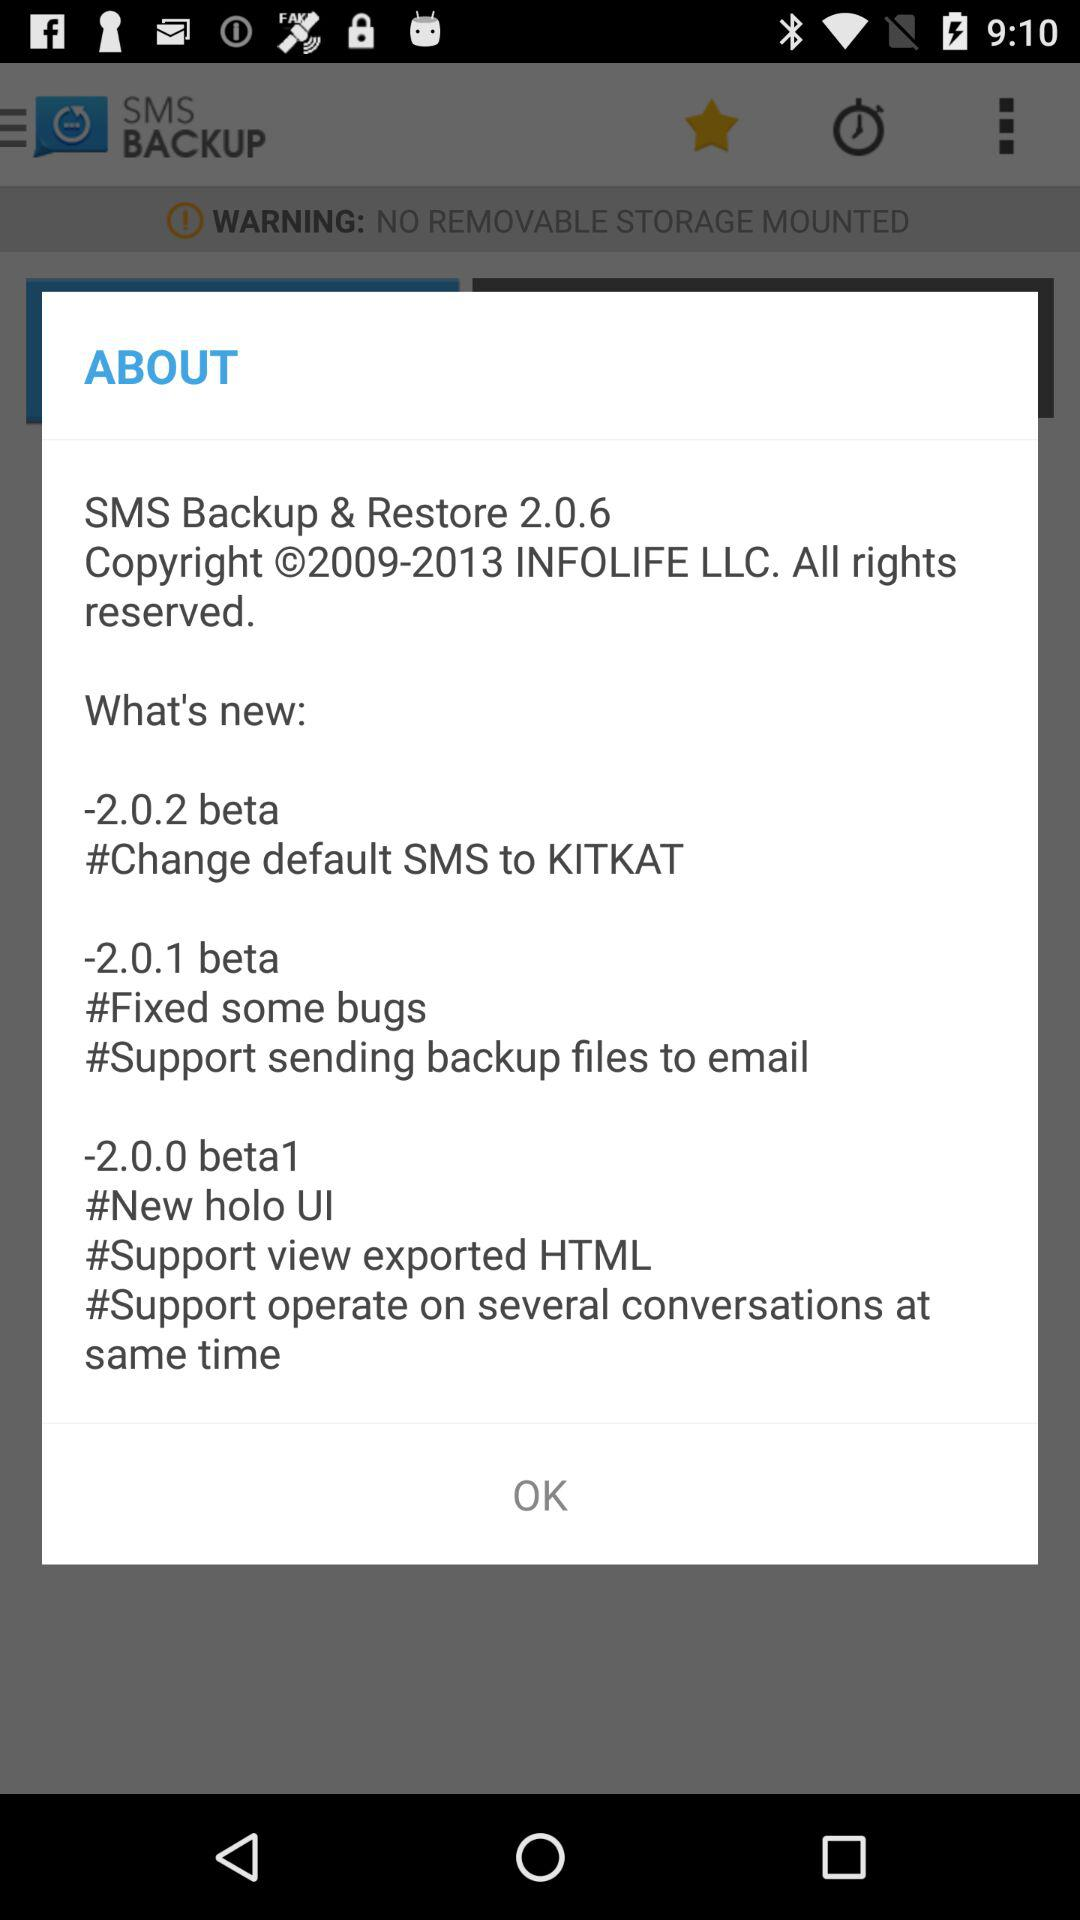What's new in 2.0.6 version?
When the provided information is insufficient, respond with <no answer>. <no answer> 